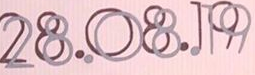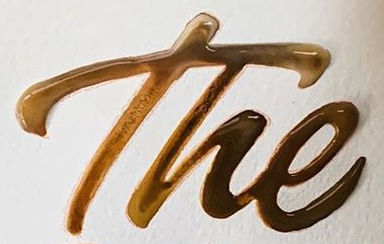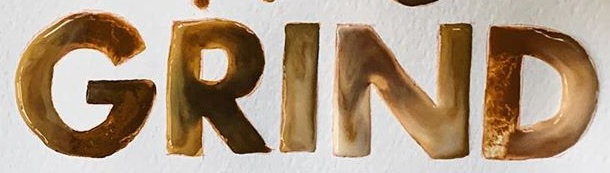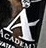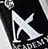Identify the words shown in these images in order, separated by a semicolon. 28.08.19; The; GRIND; A; A 